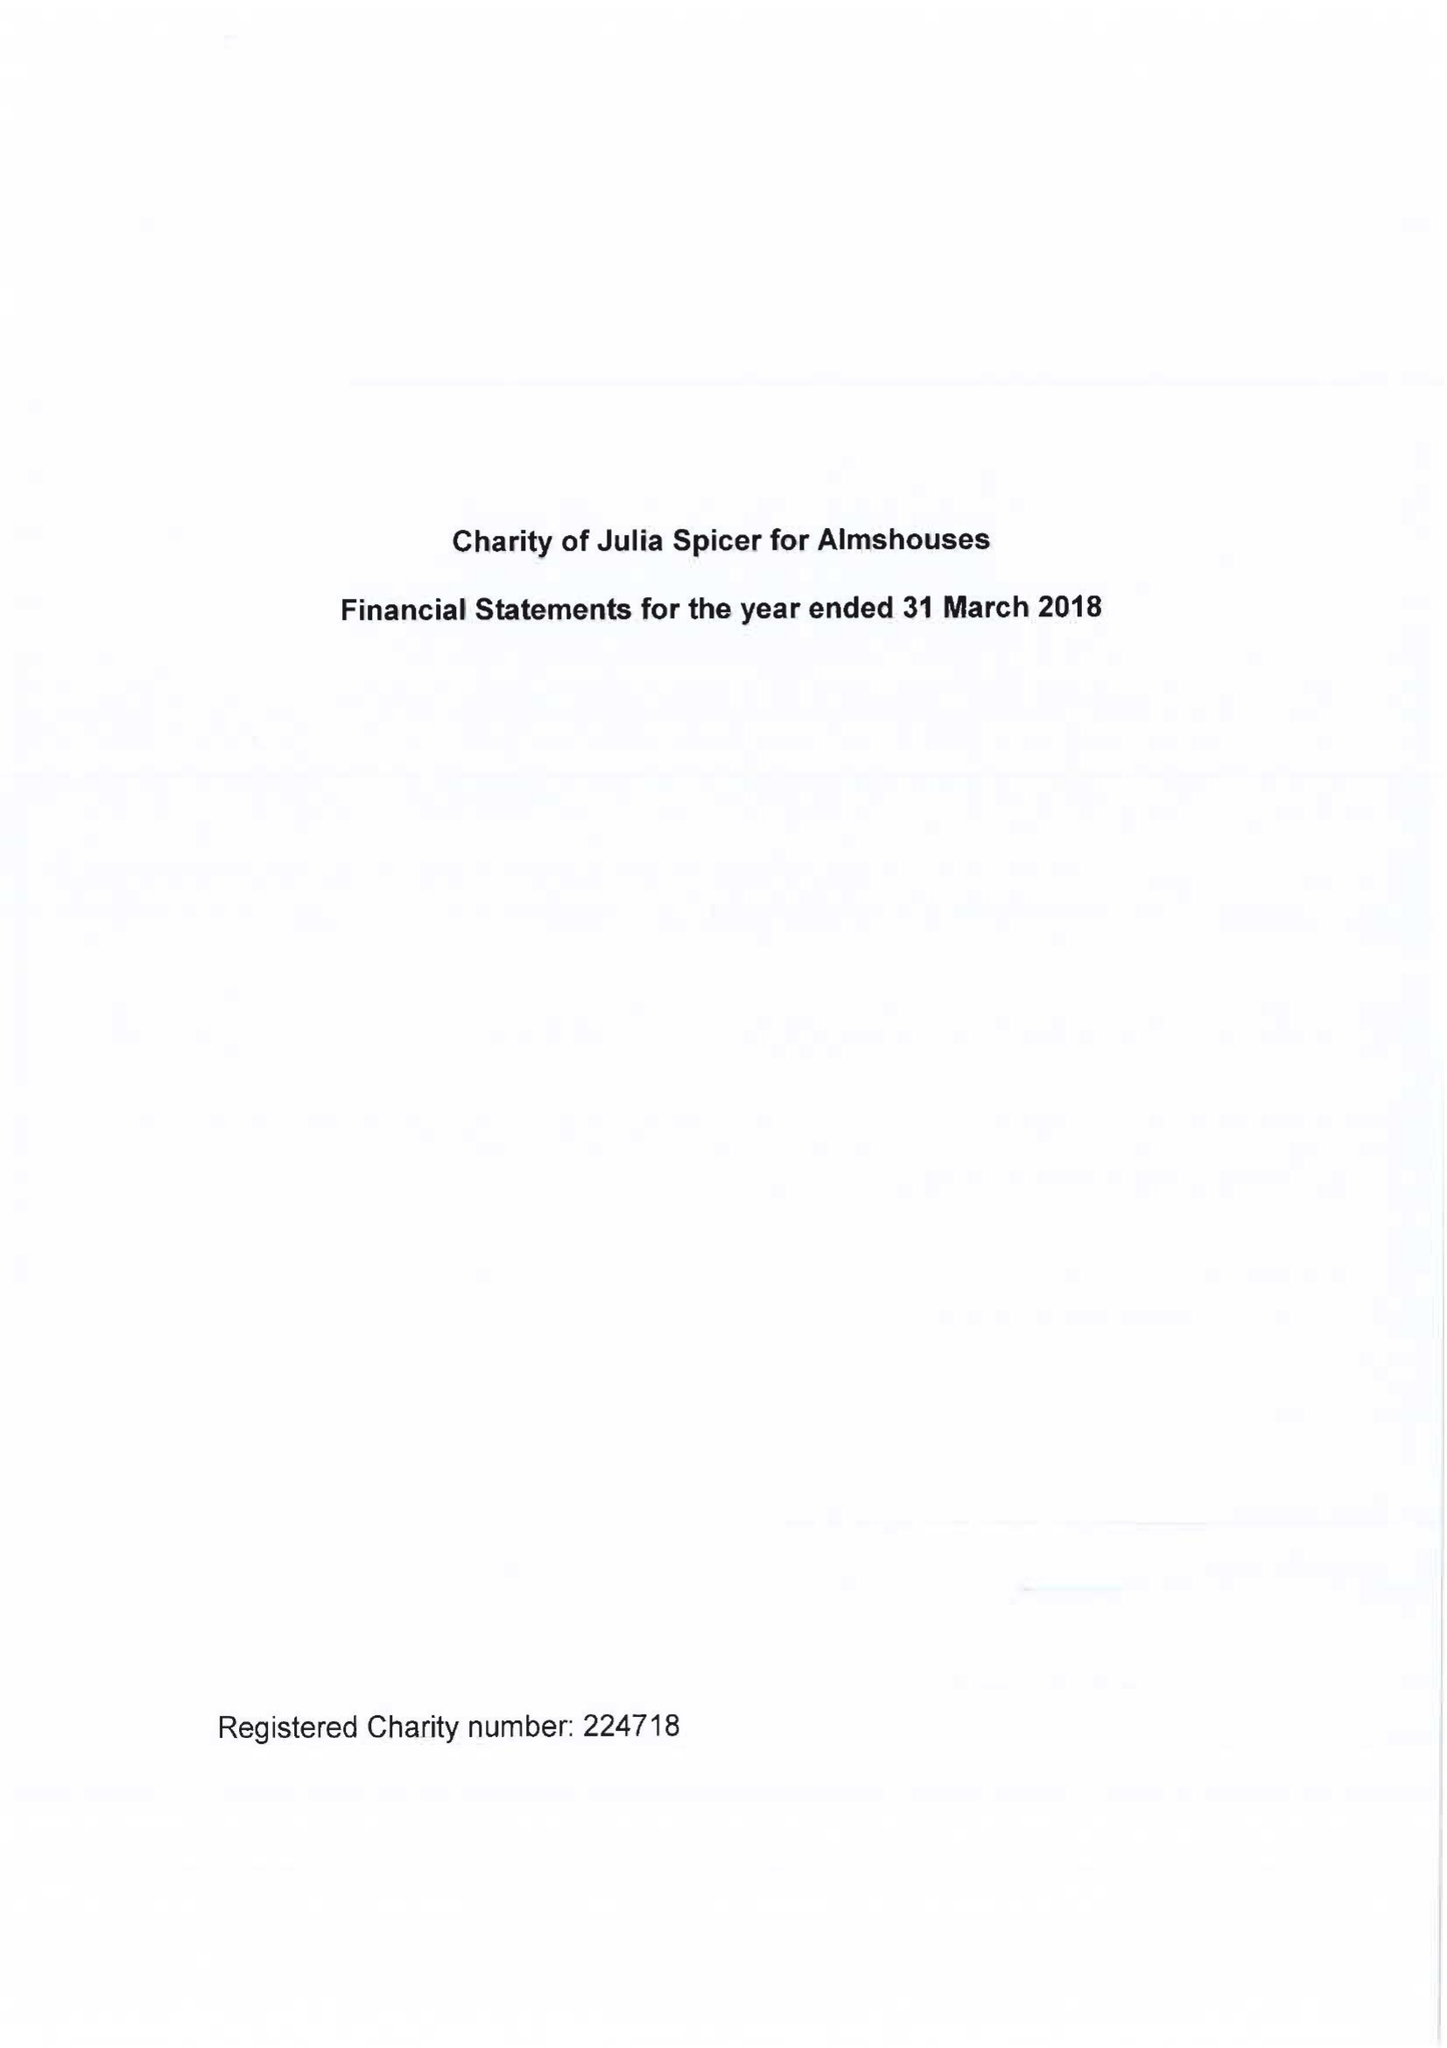What is the value for the spending_annually_in_british_pounds?
Answer the question using a single word or phrase. 25589.00 